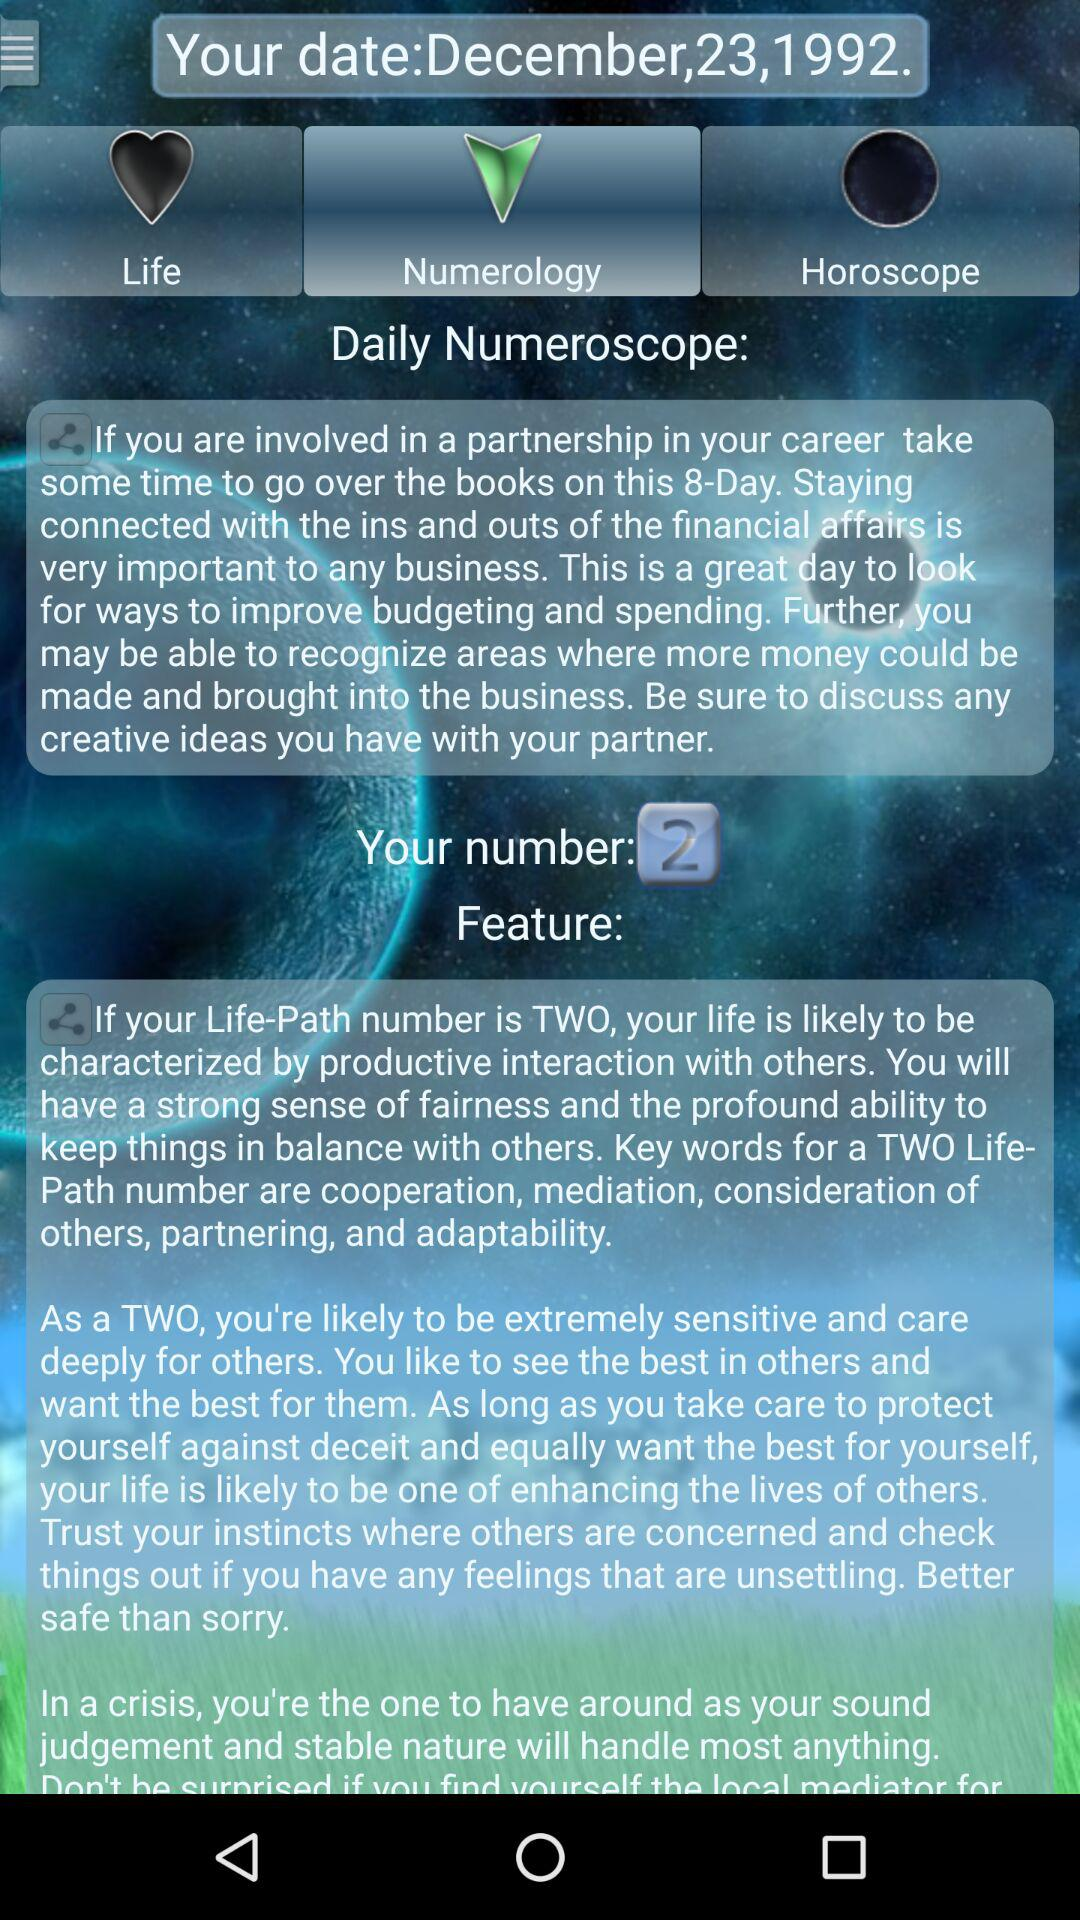Which tab is selected? The selected tab is "Numerology". 